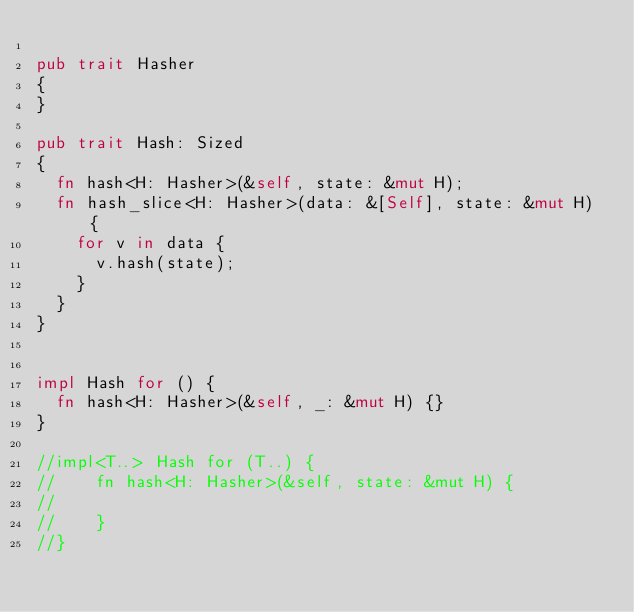Convert code to text. <code><loc_0><loc_0><loc_500><loc_500><_Rust_>
pub trait Hasher
{
}

pub trait Hash: Sized
{
	fn hash<H: Hasher>(&self, state: &mut H);
	fn hash_slice<H: Hasher>(data: &[Self], state: &mut H) {
		for v in data {
			v.hash(state);
		}
	}
}


impl Hash for () {
	fn hash<H: Hasher>(&self, _: &mut H) {}
}

//impl<T..> Hash for (T..) {
//	  fn hash<H: Hasher>(&self, state: &mut H) {
//	      
//	  }
//}
</code> 